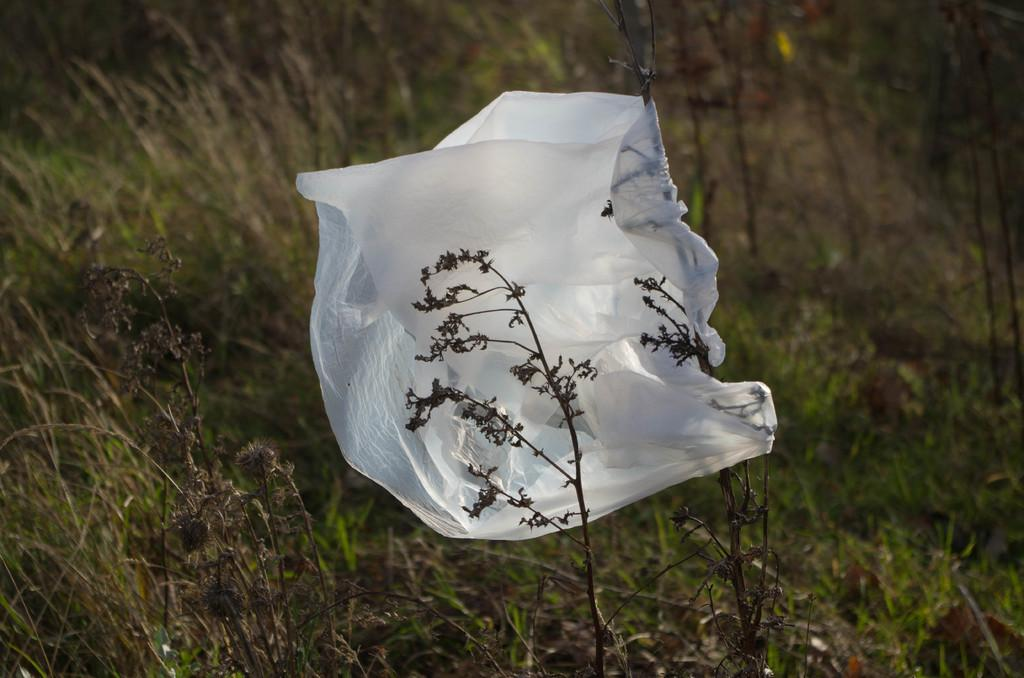What is covering the plant in the image? There is a polythene cover in the image, and it is attached to a plant. What type of vegetation is visible in the image? There is grass in the image. What is the color of the grass? The grass is green in color. How is the plant being used to measure the distance between two points in the image? The plant is not being used to measure distance in the image; it is covered by a polythene cover. 